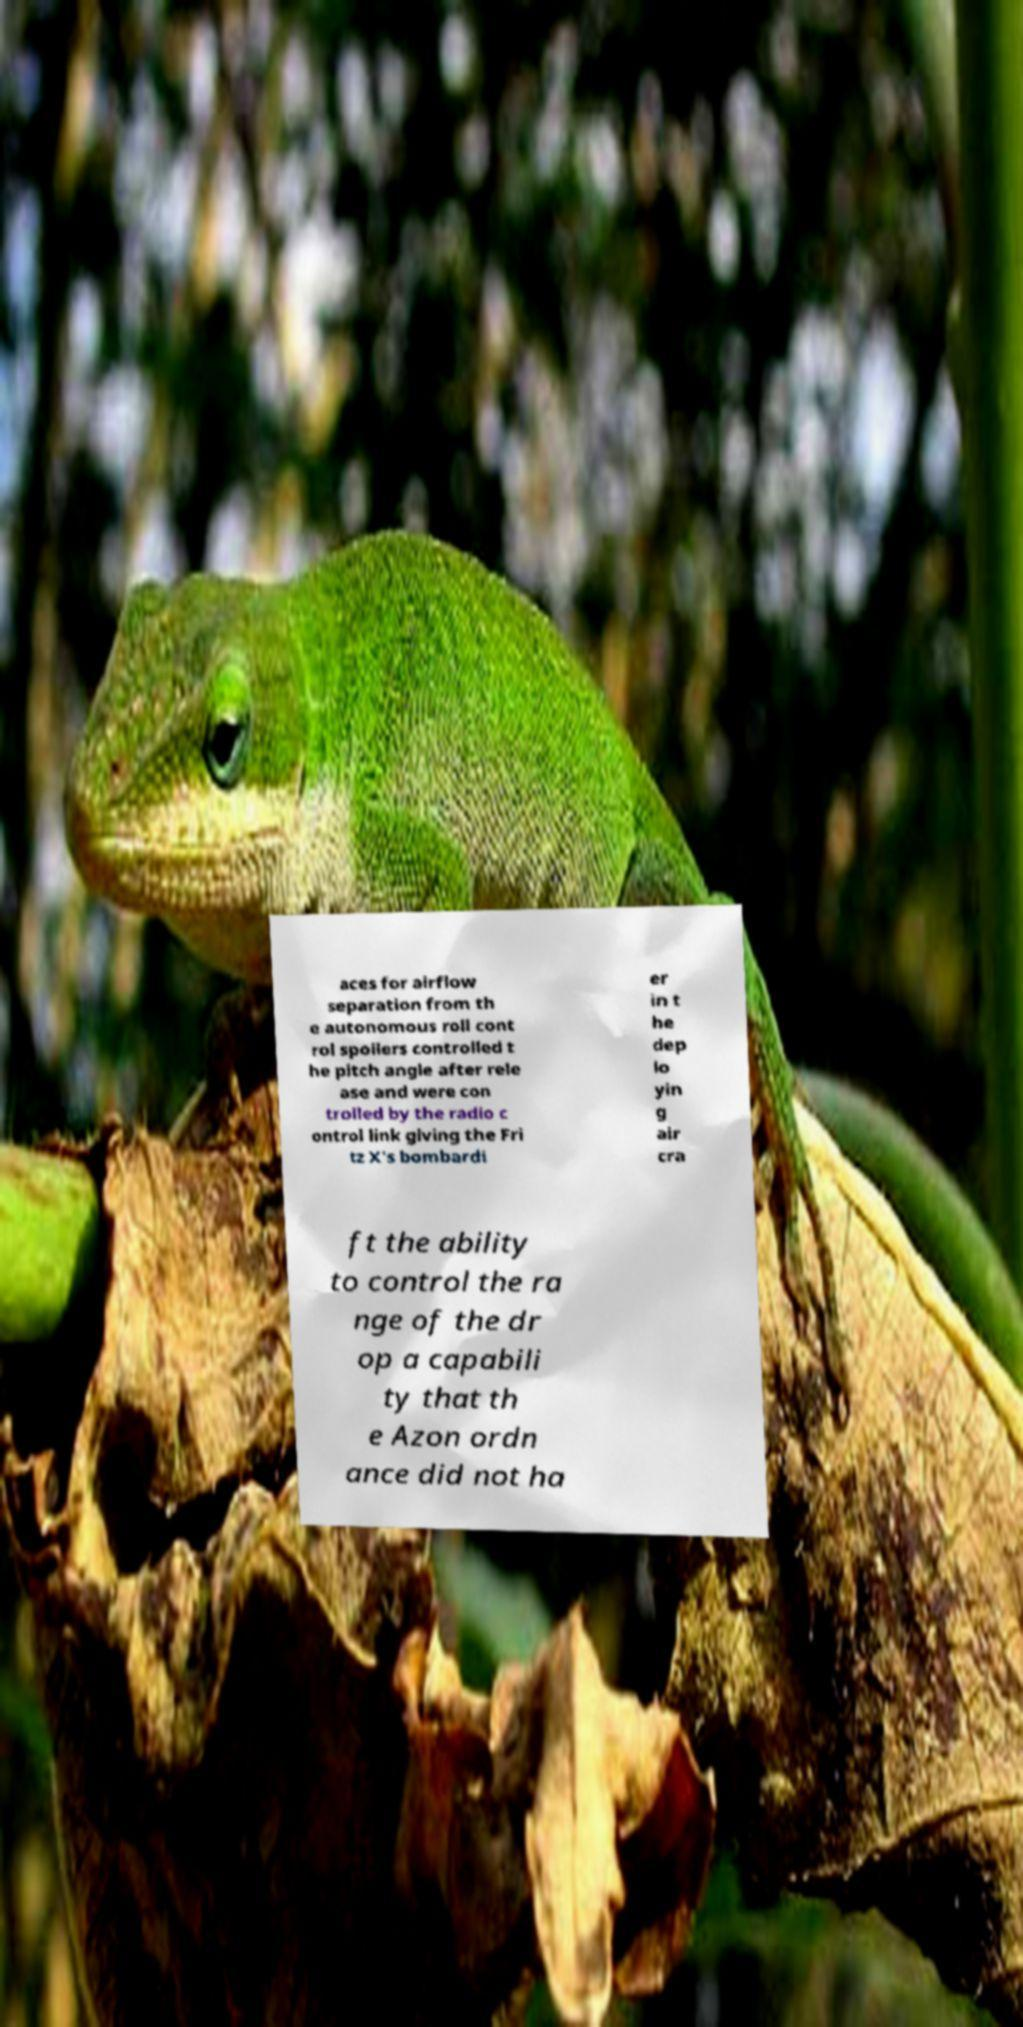There's text embedded in this image that I need extracted. Can you transcribe it verbatim? aces for airflow separation from th e autonomous roll cont rol spoilers controlled t he pitch angle after rele ase and were con trolled by the radio c ontrol link giving the Fri tz X's bombardi er in t he dep lo yin g air cra ft the ability to control the ra nge of the dr op a capabili ty that th e Azon ordn ance did not ha 